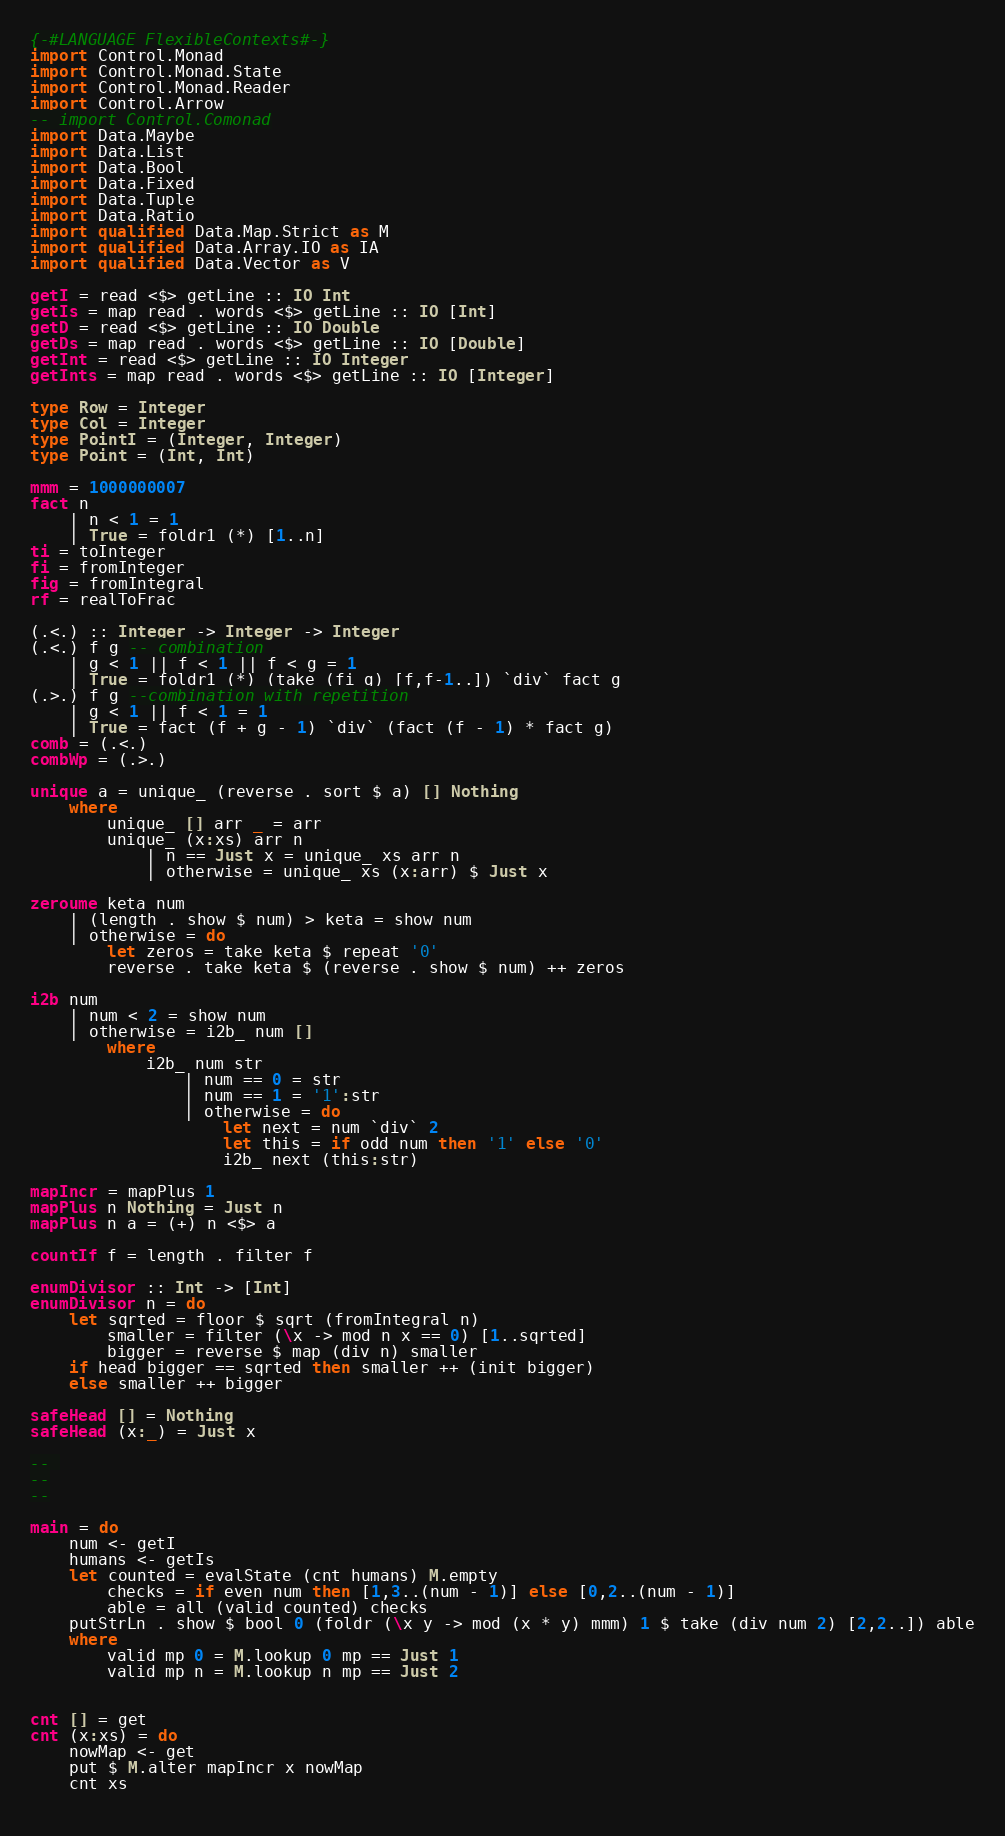<code> <loc_0><loc_0><loc_500><loc_500><_Haskell_>{-#LANGUAGE FlexibleContexts#-}
import Control.Monad
import Control.Monad.State
import Control.Monad.Reader
import Control.Arrow
-- import Control.Comonad
import Data.Maybe
import Data.List
import Data.Bool
import Data.Fixed
import Data.Tuple
import Data.Ratio
import qualified Data.Map.Strict as M
import qualified Data.Array.IO as IA
import qualified Data.Vector as V

getI = read <$> getLine :: IO Int
getIs = map read . words <$> getLine :: IO [Int]
getD = read <$> getLine :: IO Double
getDs = map read . words <$> getLine :: IO [Double]
getInt = read <$> getLine :: IO Integer
getInts = map read . words <$> getLine :: IO [Integer]

type Row = Integer
type Col = Integer
type PointI = (Integer, Integer)
type Point = (Int, Int)

mmm = 1000000007
fact n
    | n < 1 = 1
    | True = foldr1 (*) [1..n]
ti = toInteger
fi = fromInteger
fig = fromIntegral
rf = realToFrac

(.<.) :: Integer -> Integer -> Integer
(.<.) f g -- combination
    | g < 1 || f < 1 || f < g = 1
    | True = foldr1 (*) (take (fi g) [f,f-1..]) `div` fact g
(.>.) f g --combination with repetition
    | g < 1 || f < 1 = 1
    | True = fact (f + g - 1) `div` (fact (f - 1) * fact g)
comb = (.<.)
combWp = (.>.)

unique a = unique_ (reverse . sort $ a) [] Nothing
    where
        unique_ [] arr _ = arr
        unique_ (x:xs) arr n
            | n == Just x = unique_ xs arr n
            | otherwise = unique_ xs (x:arr) $ Just x
 
zeroume keta num
    | (length . show $ num) > keta = show num
    | otherwise = do 
        let zeros = take keta $ repeat '0'
        reverse . take keta $ (reverse . show $ num) ++ zeros
 
i2b num
    | num < 2 = show num
    | otherwise = i2b_ num []
        where
            i2b_ num str
                | num == 0 = str
                | num == 1 = '1':str
                | otherwise = do
                    let next = num `div` 2
                    let this = if odd num then '1' else '0'
                    i2b_ next (this:str)

mapIncr = mapPlus 1
mapPlus n Nothing = Just n
mapPlus n a = (+) n <$> a

countIf f = length . filter f

enumDivisor :: Int -> [Int]
enumDivisor n = do
    let sqrted = floor $ sqrt (fromIntegral n)
        smaller = filter (\x -> mod n x == 0) [1..sqrted]
        bigger = reverse $ map (div n) smaller
    if head bigger == sqrted then smaller ++ (init bigger)
    else smaller ++ bigger

safeHead [] = Nothing
safeHead (x:_) = Just x

-- 
--
--

main = do
    num <- getI
    humans <- getIs
    let counted = evalState (cnt humans) M.empty
        checks = if even num then [1,3..(num - 1)] else [0,2..(num - 1)]
        able = all (valid counted) checks
    putStrLn . show $ bool 0 (foldr (\x y -> mod (x * y) mmm) 1 $ take (div num 2) [2,2..]) able
    where
        valid mp 0 = M.lookup 0 mp == Just 1
        valid mp n = M.lookup n mp == Just 2


cnt [] = get
cnt (x:xs) = do
    nowMap <- get
    put $ M.alter mapIncr x nowMap
    cnt xs
    
</code> 